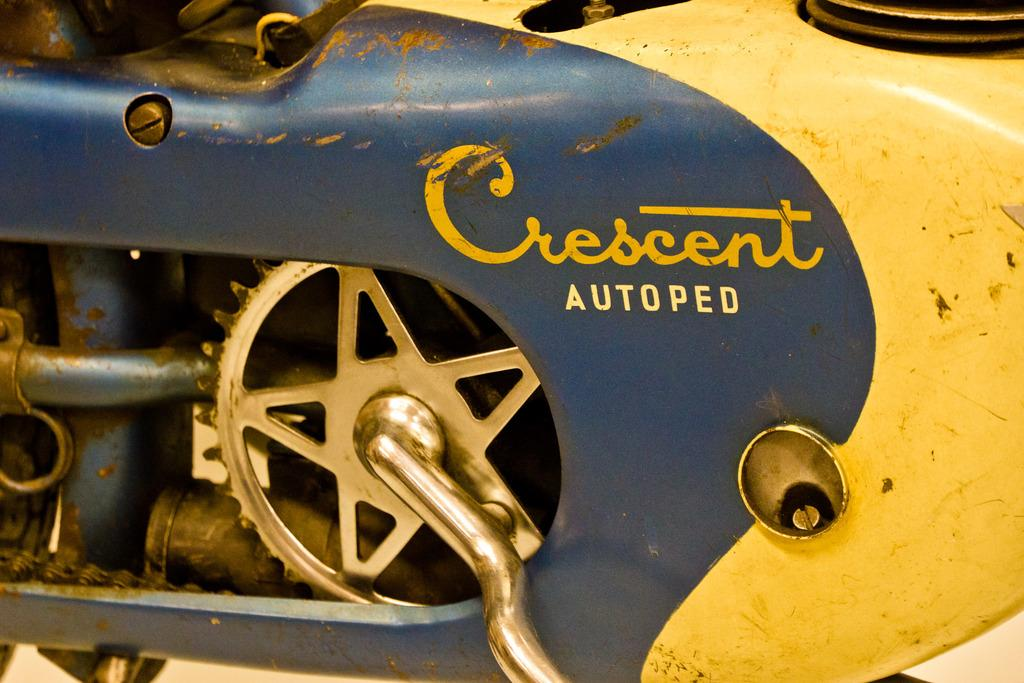What is the main subject of the image? The main subject of the image is a truncated part of a vehicle. Can you describe the condition of the vehicle part in the image? The vehicle part appears to be cut off or incomplete, as it is described as "truncated." What is the name of the person using a hammer on the vehicle in the image? There is no person using a hammer on the vehicle in the image, as it only shows a truncated part of a vehicle. What are the chances of the vehicle being repaired in the image? The image does not provide any information about the likelihood of the vehicle being repaired, as it only shows a truncated part of the vehicle. 